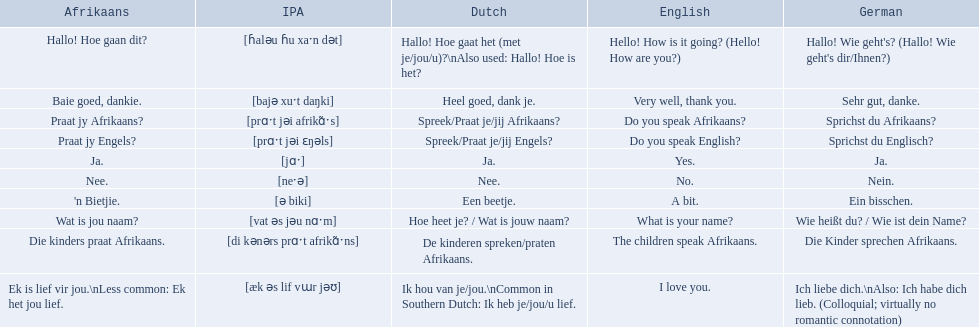How can the phrase "the children speak afrikaans" be expressed in afrikaans? Die kinders praat Afrikaans. Additionally, how can it be conveyed in german? Die Kinder sprechen Afrikaans. How can you greet someone and ask how they are doing in afrikaans? Hallo! Hoe gaan dit?. How can you express that you are doing great and show gratitude in afrikaans? Baie goed, dankie. How do you inquire if someone speaks afrikaans, in afrikaans? Praat jy Afrikaans?. 